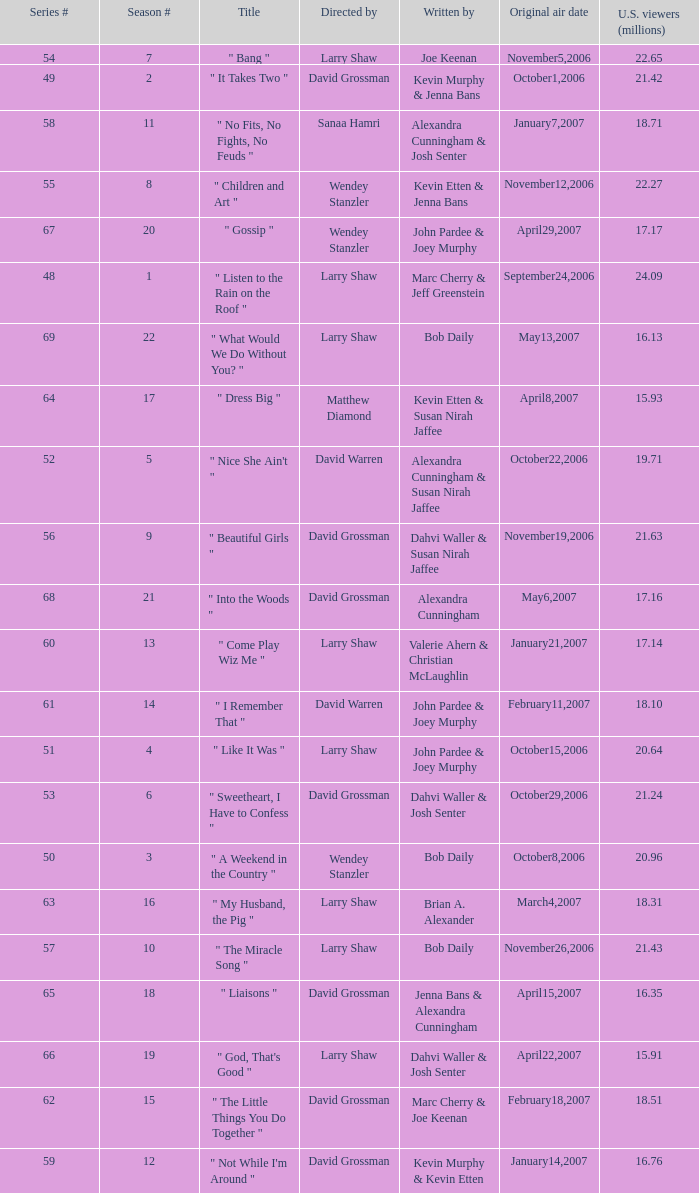What series number garnered 20.64 million viewers? 51.0. Could you help me parse every detail presented in this table? {'header': ['Series #', 'Season #', 'Title', 'Directed by', 'Written by', 'Original air date', 'U.S. viewers (millions)'], 'rows': [['54', '7', '" Bang "', 'Larry Shaw', 'Joe Keenan', 'November5,2006', '22.65'], ['49', '2', '" It Takes Two "', 'David Grossman', 'Kevin Murphy & Jenna Bans', 'October1,2006', '21.42'], ['58', '11', '" No Fits, No Fights, No Feuds "', 'Sanaa Hamri', 'Alexandra Cunningham & Josh Senter', 'January7,2007', '18.71'], ['55', '8', '" Children and Art "', 'Wendey Stanzler', 'Kevin Etten & Jenna Bans', 'November12,2006', '22.27'], ['67', '20', '" Gossip "', 'Wendey Stanzler', 'John Pardee & Joey Murphy', 'April29,2007', '17.17'], ['48', '1', '" Listen to the Rain on the Roof "', 'Larry Shaw', 'Marc Cherry & Jeff Greenstein', 'September24,2006', '24.09'], ['69', '22', '" What Would We Do Without You? "', 'Larry Shaw', 'Bob Daily', 'May13,2007', '16.13'], ['64', '17', '" Dress Big "', 'Matthew Diamond', 'Kevin Etten & Susan Nirah Jaffee', 'April8,2007', '15.93'], ['52', '5', '" Nice She Ain\'t "', 'David Warren', 'Alexandra Cunningham & Susan Nirah Jaffee', 'October22,2006', '19.71'], ['56', '9', '" Beautiful Girls "', 'David Grossman', 'Dahvi Waller & Susan Nirah Jaffee', 'November19,2006', '21.63'], ['68', '21', '" Into the Woods "', 'David Grossman', 'Alexandra Cunningham', 'May6,2007', '17.16'], ['60', '13', '" Come Play Wiz Me "', 'Larry Shaw', 'Valerie Ahern & Christian McLaughlin', 'January21,2007', '17.14'], ['61', '14', '" I Remember That "', 'David Warren', 'John Pardee & Joey Murphy', 'February11,2007', '18.10'], ['51', '4', '" Like It Was "', 'Larry Shaw', 'John Pardee & Joey Murphy', 'October15,2006', '20.64'], ['53', '6', '" Sweetheart, I Have to Confess "', 'David Grossman', 'Dahvi Waller & Josh Senter', 'October29,2006', '21.24'], ['50', '3', '" A Weekend in the Country "', 'Wendey Stanzler', 'Bob Daily', 'October8,2006', '20.96'], ['63', '16', '" My Husband, the Pig "', 'Larry Shaw', 'Brian A. Alexander', 'March4,2007', '18.31'], ['57', '10', '" The Miracle Song "', 'Larry Shaw', 'Bob Daily', 'November26,2006', '21.43'], ['65', '18', '" Liaisons "', 'David Grossman', 'Jenna Bans & Alexandra Cunningham', 'April15,2007', '16.35'], ['66', '19', '" God, That\'s Good "', 'Larry Shaw', 'Dahvi Waller & Josh Senter', 'April22,2007', '15.91'], ['62', '15', '" The Little Things You Do Together "', 'David Grossman', 'Marc Cherry & Joe Keenan', 'February18,2007', '18.51'], ['59', '12', '" Not While I\'m Around "', 'David Grossman', 'Kevin Murphy & Kevin Etten', 'January14,2007', '16.76']]} 